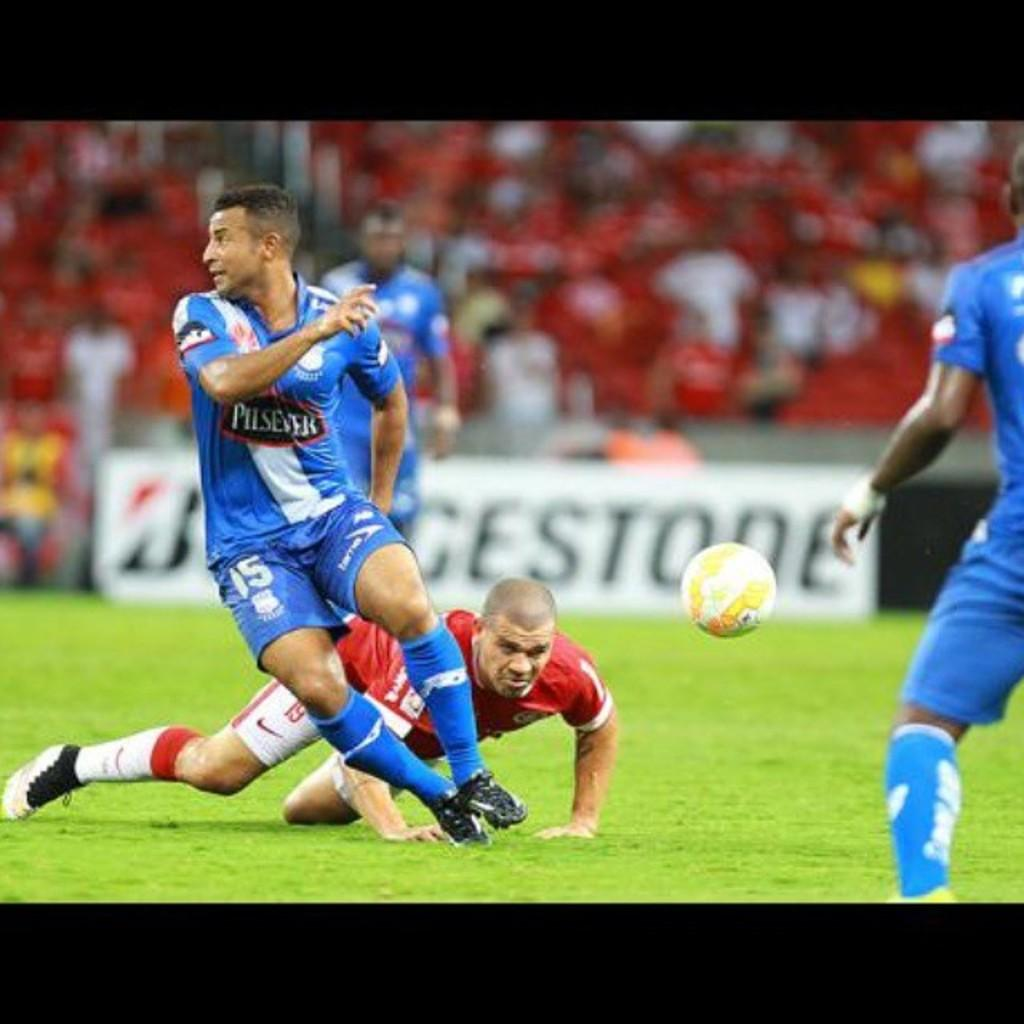<image>
Create a compact narrative representing the image presented. two soccer teams playing on a field sponsored by bridgestone 